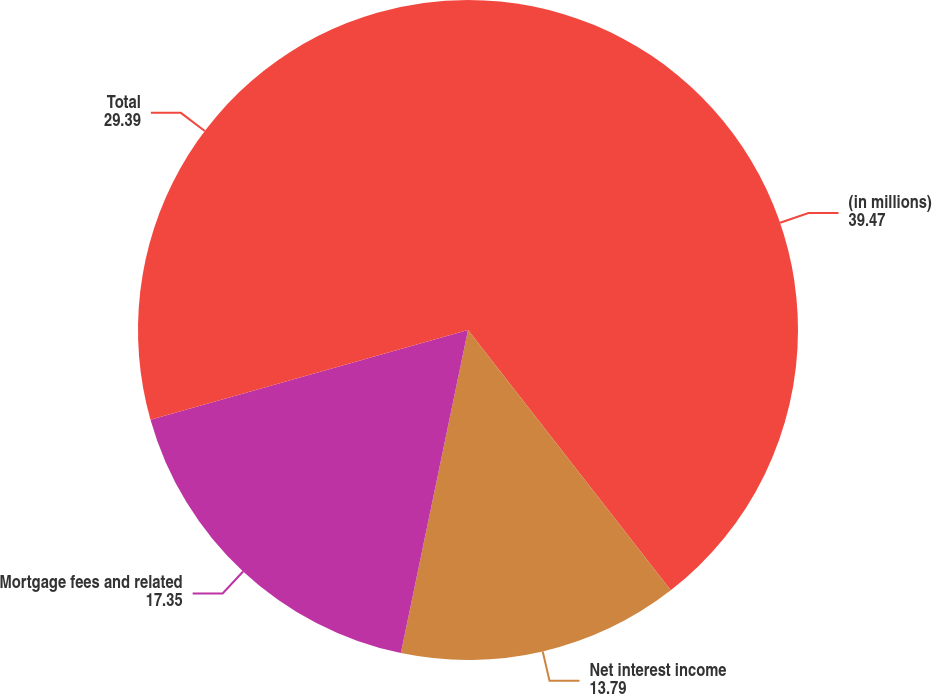Convert chart. <chart><loc_0><loc_0><loc_500><loc_500><pie_chart><fcel>(in millions)<fcel>Net interest income<fcel>Mortgage fees and related<fcel>Total<nl><fcel>39.47%<fcel>13.79%<fcel>17.35%<fcel>29.39%<nl></chart> 